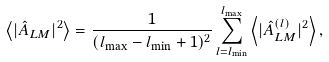<formula> <loc_0><loc_0><loc_500><loc_500>\left \langle | \hat { A } _ { L M } | ^ { 2 } \right \rangle = \frac { 1 } { ( l _ { \max } - l _ { \min } + 1 ) ^ { 2 } } \sum _ { l = l _ { \min } } ^ { l _ { \max } } \left \langle | \hat { A } ^ { ( l ) } _ { L M } | ^ { 2 } \right \rangle ,</formula> 